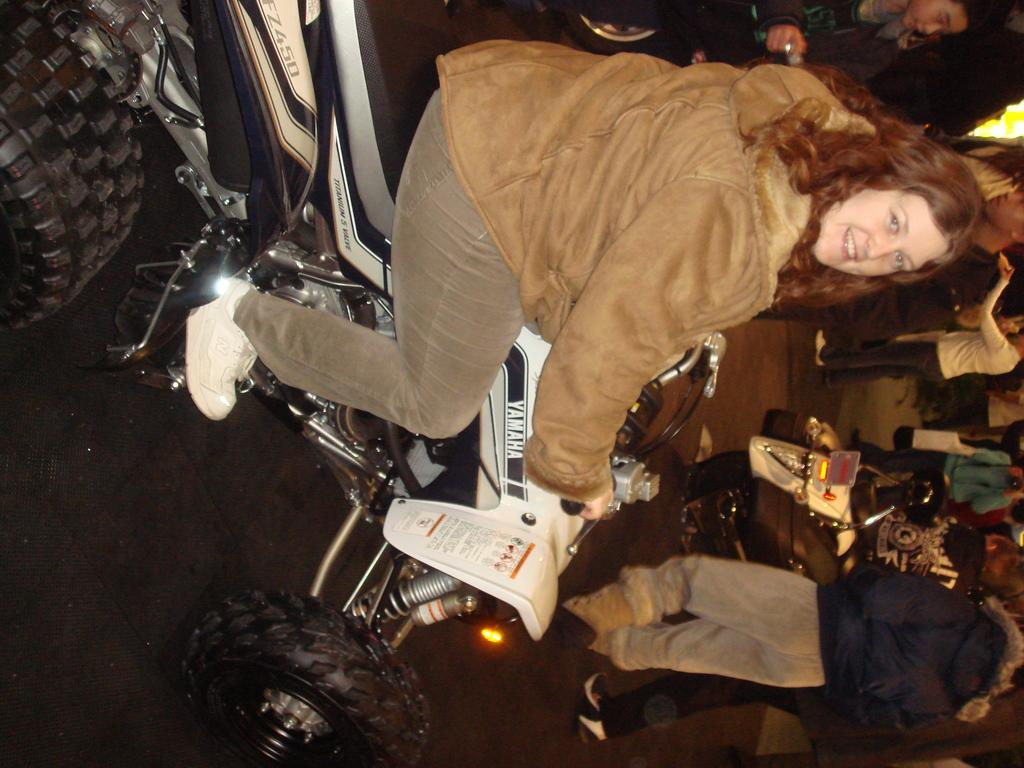Who is the main subject in the image? There is a lady in the image. What is the lady doing in the image? The lady is sitting on a bike and smiling. Can you describe the background of the image? There are people and another vehicle visible in the background. What type of scissors is the lady using to cut the amusement park ride in the image? There is no amusement park ride or scissors present in the image. The lady is sitting on a bike and smiling, with people and another vehicle visible in the background. 